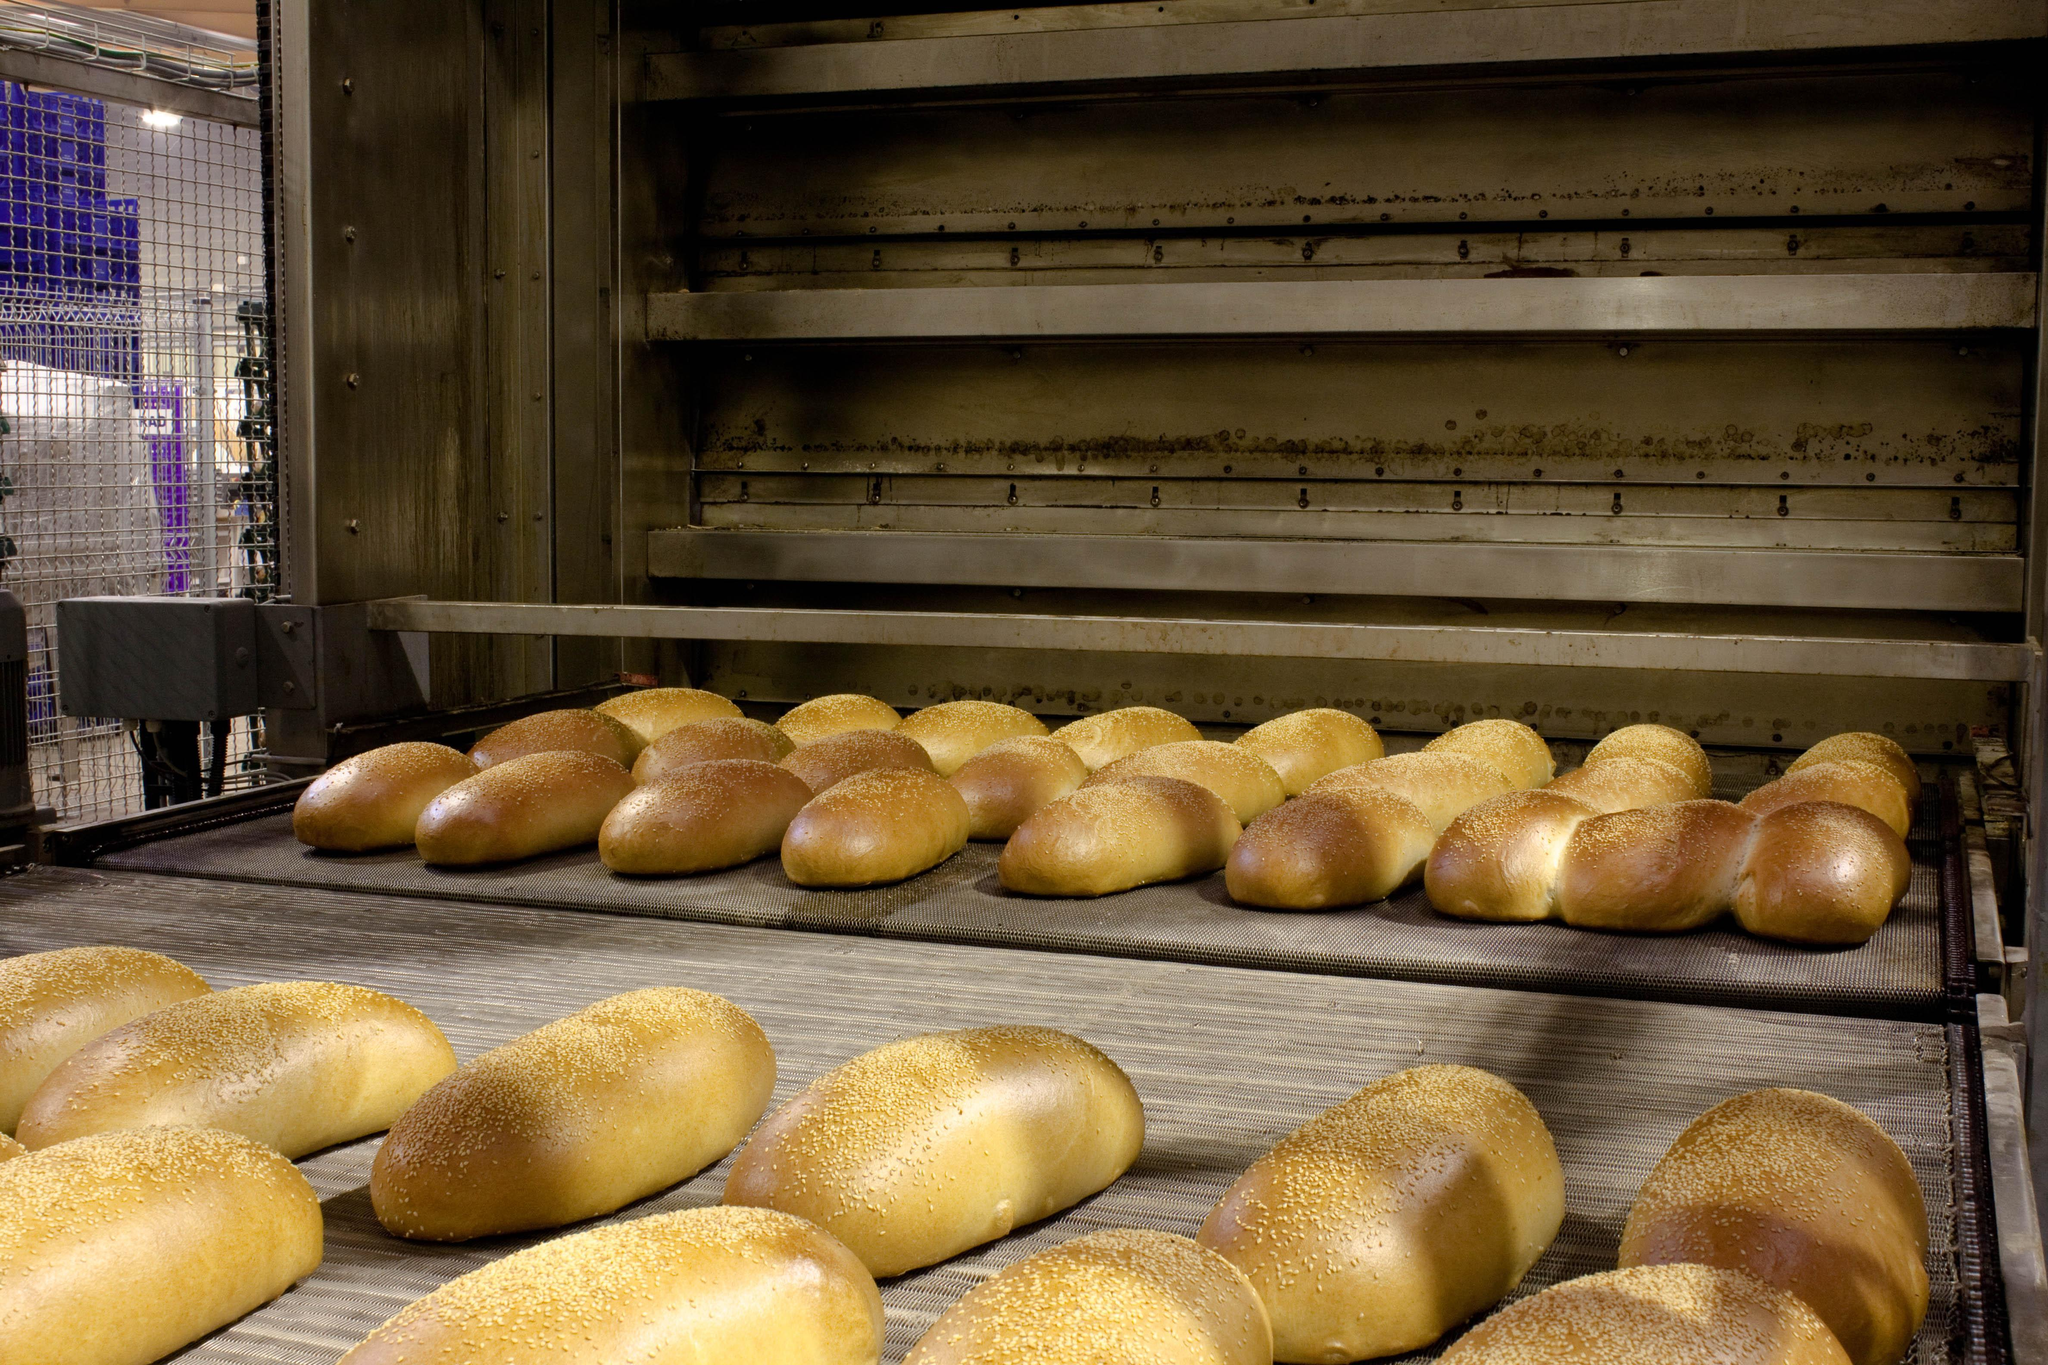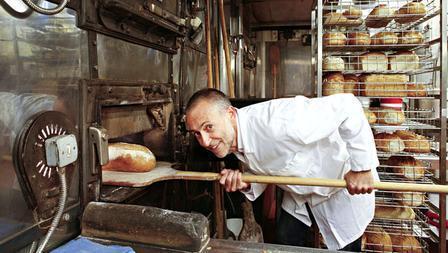The first image is the image on the left, the second image is the image on the right. Given the left and right images, does the statement "The right image shows a smiling man in a white shirt bending forward by racks of bread." hold true? Answer yes or no. Yes. The first image is the image on the left, the second image is the image on the right. Analyze the images presented: Is the assertion "A baker in a white shirt and hat works in the kitchen in one of the images." valid? Answer yes or no. No. 